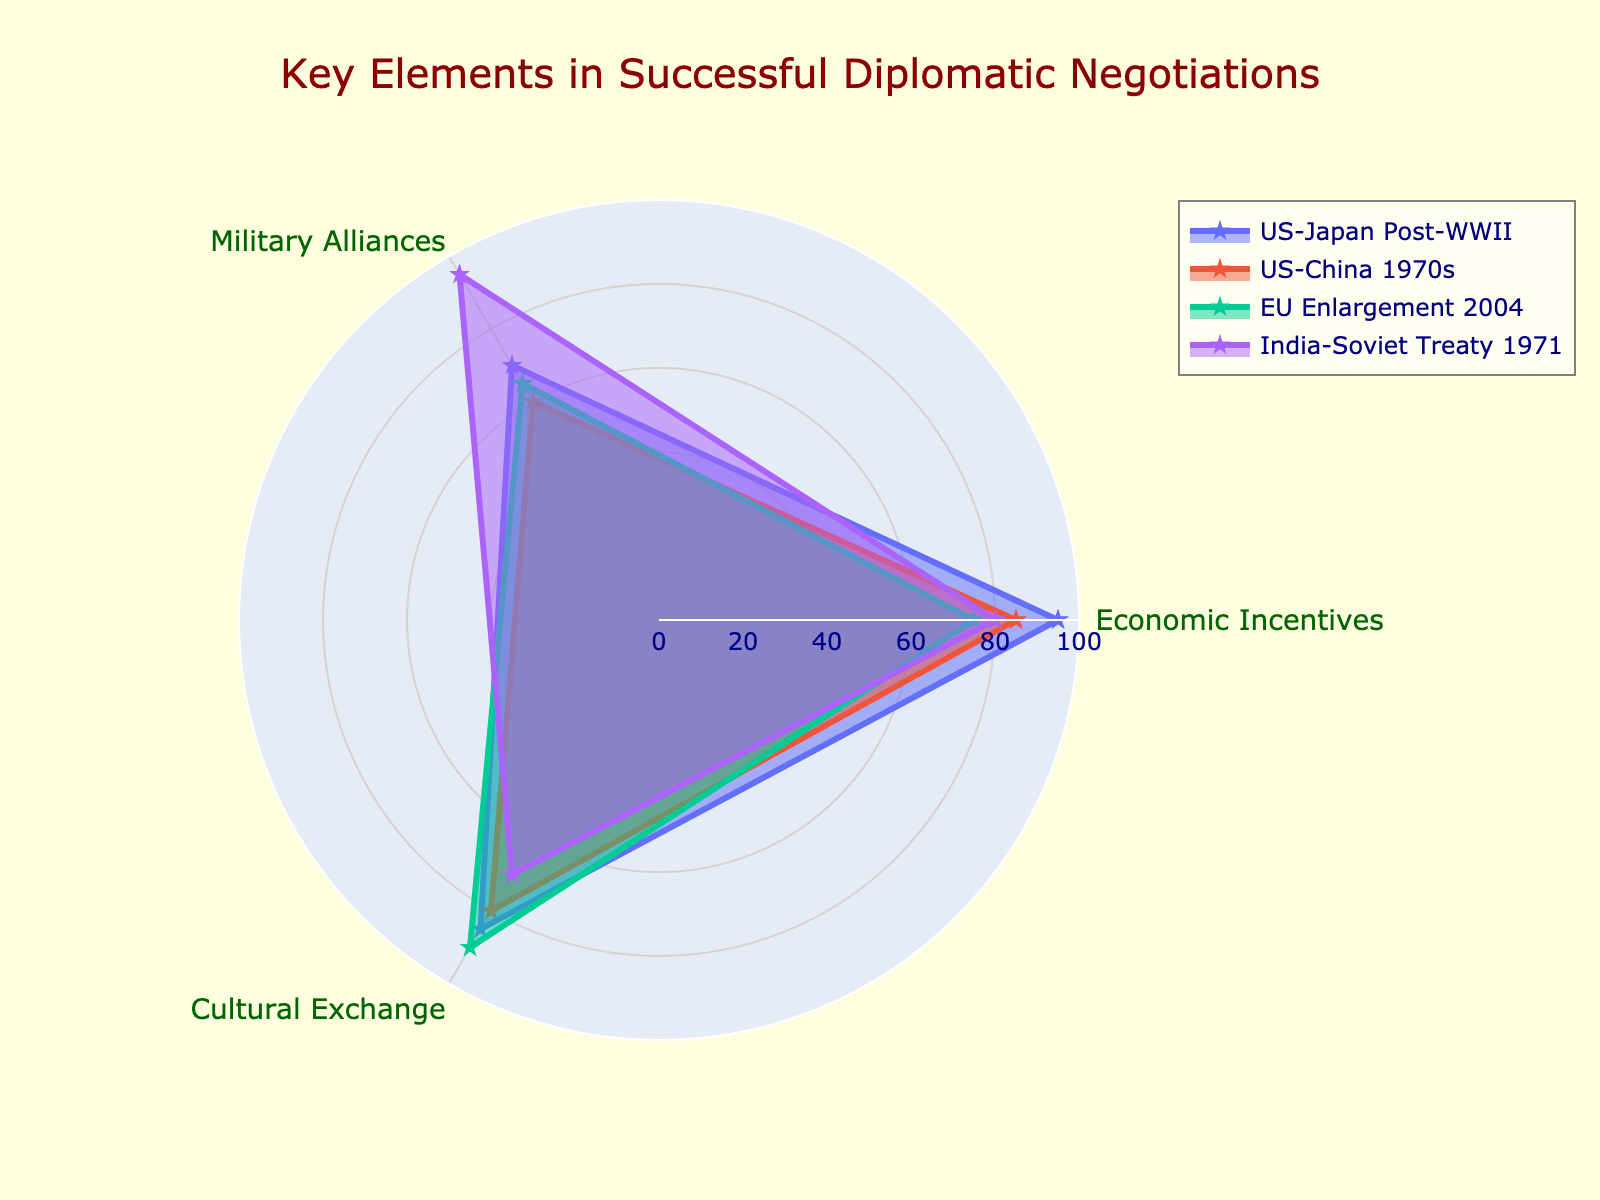What is the title of the radar chart? The radar chart typically displays the title prominently at the top of the figure.
Answer: Key Elements in Successful Diplomatic Negotiations Which group has the highest value in Economic Incentives? The radar chart shows values at different points of each axis. Identify the values for Economic Incentives and find the highest.
Answer: US-Japan Post-WWII What is the average value of Military Alliances across all groups? Sum the Military Alliances values for all groups (70 + 60 + 65 + 95) and then divide by the number of groups (4). The average is (70 + 60 + 65 + 95) / 4 = 72.5.
Answer: 72.5 Which diplomatic negotiation has the lowest Cultural Exchange value? Compare the Cultural Exchange values for each group and find the lowest. The values are 85, 80, 90, and 70. The lowest is 70.
Answer: India-Soviet Treaty 1971 What is the range of Economic Incentives values across all groups? Find the minimum and maximum values of Economic Incentives (75 and 95) and calculate the difference: 95 - 75 = 20.
Answer: 20 Which group has the smallest variation across the three elements? Calculate the range (max - min) for each group. US-Japan Post-WWII: (95-70 = 25), US-China 1970s: (85-60 = 25), EU Enlargement 2004: (90-65 = 25), India-Soviet Treaty 1971: (95-70 = 25). All groups have the same variation of 25.
Answer: All groups have the same variation Between US-Japan Post-WWII and US-China 1970s, which group has higher overall values for all three elements combined? Sum the values for each group. US-Japan Post-WWII: (95 + 70 + 85 = 250), US-China 1970s: (85 + 60 + 80 = 225). US-Japan Post-WWII has higher overall values.
Answer: US-Japan Post-WWII Which diplomatic negotiation has the most balanced distribution of values across the three elements? A balanced distribution means values are close to each other. Compare the differences between the maximum and minimum values within each group. India-Soviet Treaty 1971 (95, 80, 70) has values that are relatively close together compared to the other groups.
Answer: India-Soviet Treaty 1971 How do the Cultural Exchange values for EU Enlargement 2004 and US-China 1970s compare? Compare the Cultural Exchange values for both groups. EU Enlargement 2004 has a value of 90, while US-China 1970s has a value of 80.
Answer: EU Enlargement 2004 is higher Which element has the highest single value among all groups? Identify the highest value of each element and compare them. Economic Incentives: 95 (US-Japan Post-WWII), Military Alliances: 95 (India-Soviet Treaty 1971), Cultural Exchange: 90 (EU Enlargement 2004). The highest single value is 95.
Answer: Economic Incentives and Military Alliances (95) 